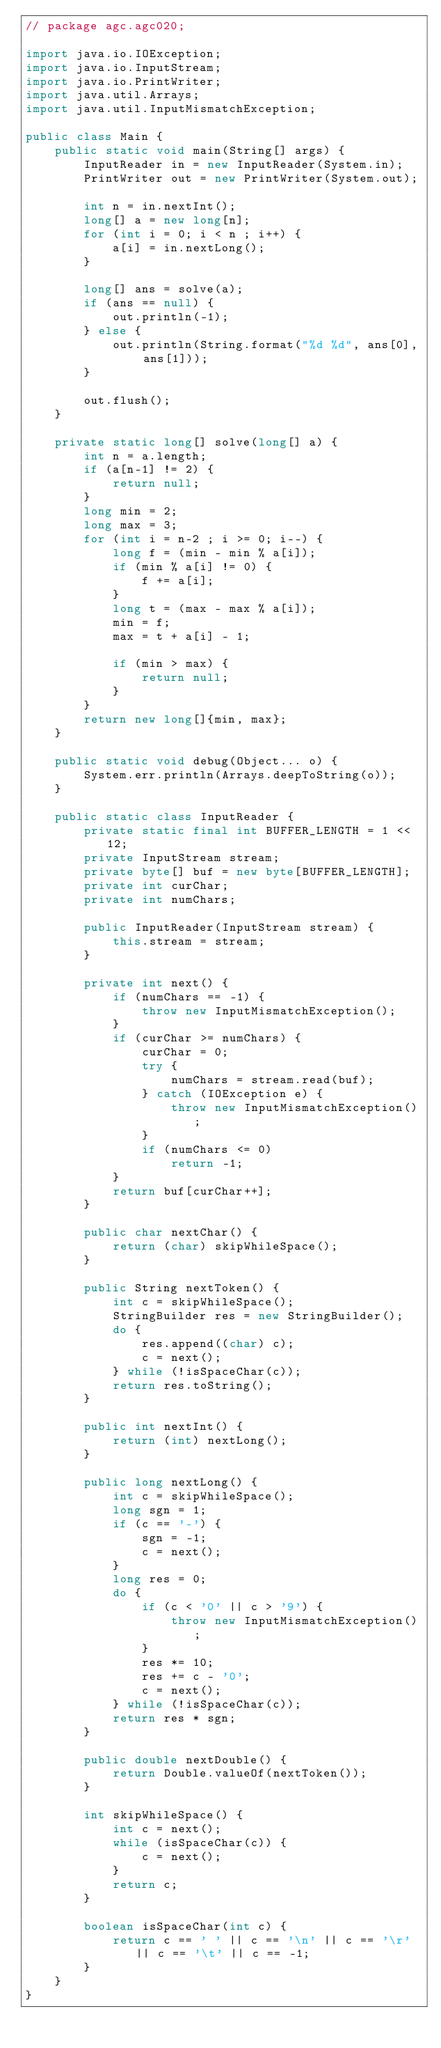Convert code to text. <code><loc_0><loc_0><loc_500><loc_500><_Java_>// package agc.agc020;

import java.io.IOException;
import java.io.InputStream;
import java.io.PrintWriter;
import java.util.Arrays;
import java.util.InputMismatchException;

public class Main {
    public static void main(String[] args) {
        InputReader in = new InputReader(System.in);
        PrintWriter out = new PrintWriter(System.out);

        int n = in.nextInt();
        long[] a = new long[n];
        for (int i = 0; i < n ; i++) {
            a[i] = in.nextLong();
        }

        long[] ans = solve(a);
        if (ans == null) {
            out.println(-1);
        } else {
            out.println(String.format("%d %d", ans[0], ans[1]));
        }

        out.flush();
    }

    private static long[] solve(long[] a) {
        int n = a.length;
        if (a[n-1] != 2) {
            return null;
        }
        long min = 2;
        long max = 3;
        for (int i = n-2 ; i >= 0; i--) {
            long f = (min - min % a[i]);
            if (min % a[i] != 0) {
                f += a[i];
            }
            long t = (max - max % a[i]);
            min = f;
            max = t + a[i] - 1;

            if (min > max) {
                return null;
            }
        }
        return new long[]{min, max};
    }

    public static void debug(Object... o) {
        System.err.println(Arrays.deepToString(o));
    }

    public static class InputReader {
        private static final int BUFFER_LENGTH = 1 << 12;
        private InputStream stream;
        private byte[] buf = new byte[BUFFER_LENGTH];
        private int curChar;
        private int numChars;

        public InputReader(InputStream stream) {
            this.stream = stream;
        }

        private int next() {
            if (numChars == -1) {
                throw new InputMismatchException();
            }
            if (curChar >= numChars) {
                curChar = 0;
                try {
                    numChars = stream.read(buf);
                } catch (IOException e) {
                    throw new InputMismatchException();
                }
                if (numChars <= 0)
                    return -1;
            }
            return buf[curChar++];
        }

        public char nextChar() {
            return (char) skipWhileSpace();
        }

        public String nextToken() {
            int c = skipWhileSpace();
            StringBuilder res = new StringBuilder();
            do {
                res.append((char) c);
                c = next();
            } while (!isSpaceChar(c));
            return res.toString();
        }

        public int nextInt() {
            return (int) nextLong();
        }

        public long nextLong() {
            int c = skipWhileSpace();
            long sgn = 1;
            if (c == '-') {
                sgn = -1;
                c = next();
            }
            long res = 0;
            do {
                if (c < '0' || c > '9') {
                    throw new InputMismatchException();
                }
                res *= 10;
                res += c - '0';
                c = next();
            } while (!isSpaceChar(c));
            return res * sgn;
        }

        public double nextDouble() {
            return Double.valueOf(nextToken());
        }

        int skipWhileSpace() {
            int c = next();
            while (isSpaceChar(c)) {
                c = next();
            }
            return c;
        }

        boolean isSpaceChar(int c) {
            return c == ' ' || c == '\n' || c == '\r' || c == '\t' || c == -1;
        }
    }
}</code> 